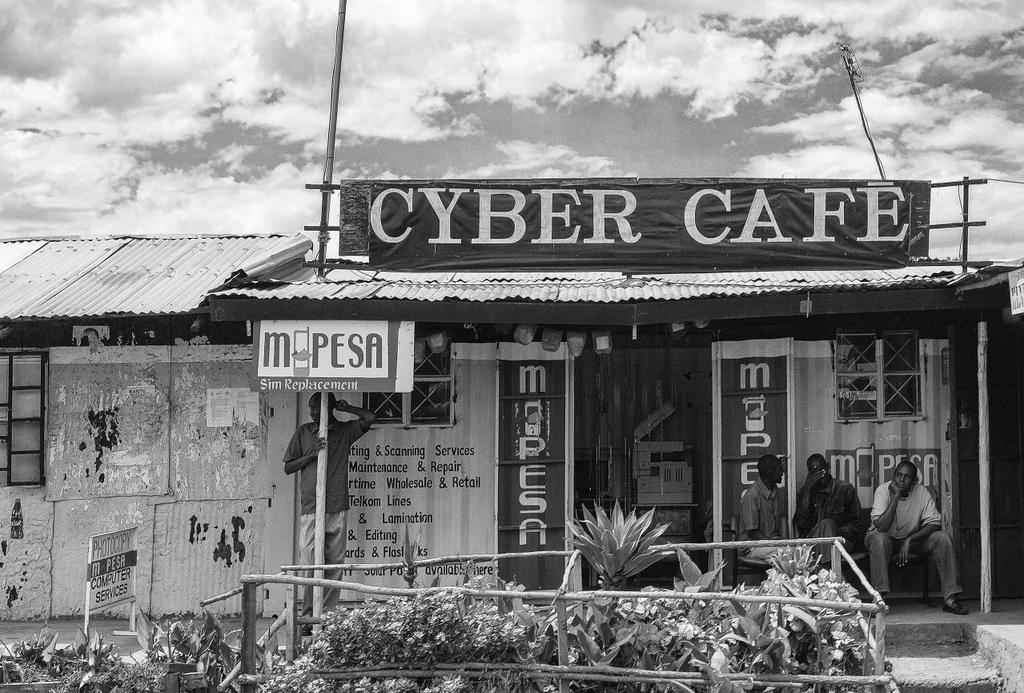<image>
Summarize the visual content of the image. A cafe depicted in a black & white phot called the Cyber Cafe. 